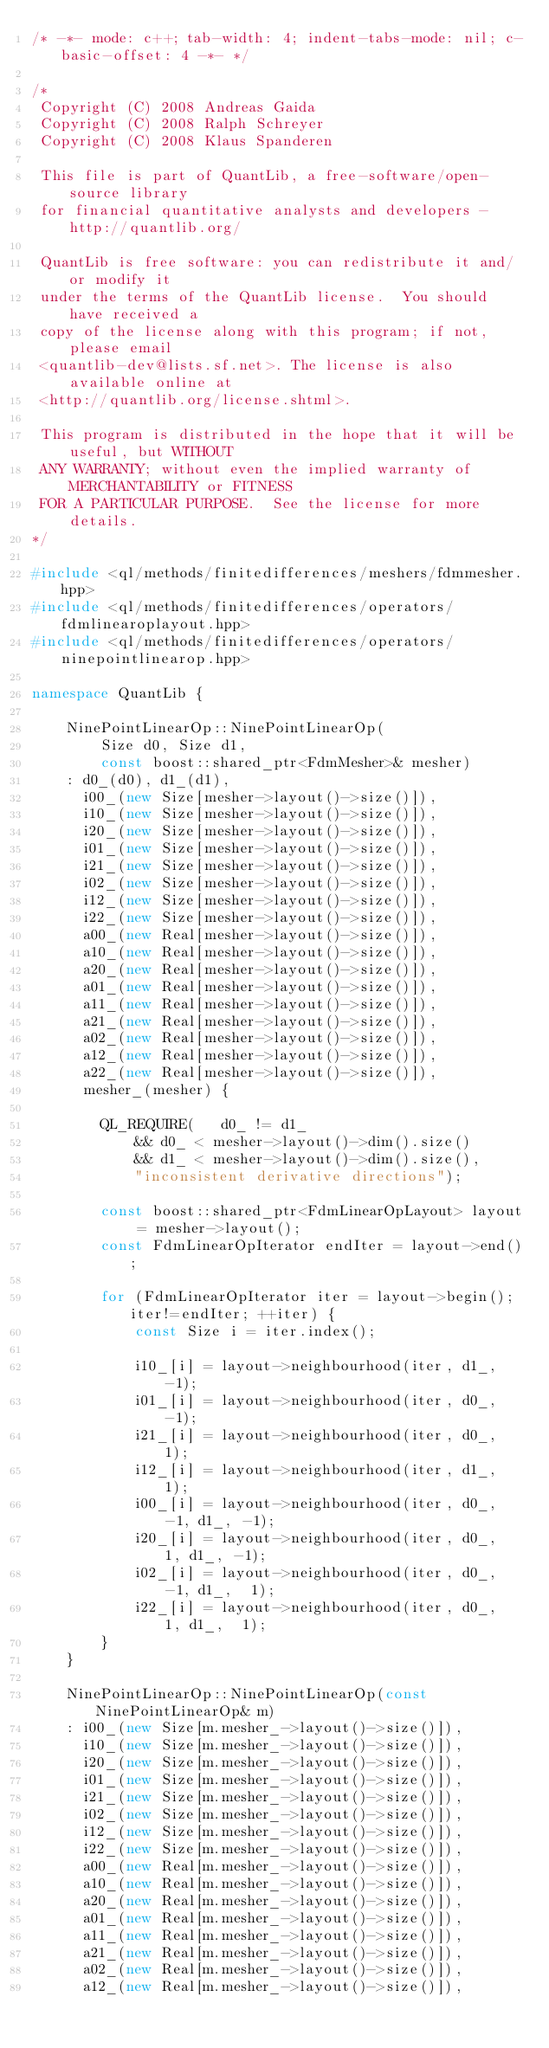Convert code to text. <code><loc_0><loc_0><loc_500><loc_500><_C++_>/* -*- mode: c++; tab-width: 4; indent-tabs-mode: nil; c-basic-offset: 4 -*- */

/*
 Copyright (C) 2008 Andreas Gaida
 Copyright (C) 2008 Ralph Schreyer
 Copyright (C) 2008 Klaus Spanderen

 This file is part of QuantLib, a free-software/open-source library
 for financial quantitative analysts and developers - http://quantlib.org/

 QuantLib is free software: you can redistribute it and/or modify it
 under the terms of the QuantLib license.  You should have received a
 copy of the license along with this program; if not, please email
 <quantlib-dev@lists.sf.net>. The license is also available online at
 <http://quantlib.org/license.shtml>.

 This program is distributed in the hope that it will be useful, but WITHOUT
 ANY WARRANTY; without even the implied warranty of MERCHANTABILITY or FITNESS
 FOR A PARTICULAR PURPOSE.  See the license for more details.
*/

#include <ql/methods/finitedifferences/meshers/fdmmesher.hpp>
#include <ql/methods/finitedifferences/operators/fdmlinearoplayout.hpp>
#include <ql/methods/finitedifferences/operators/ninepointlinearop.hpp>

namespace QuantLib {

    NinePointLinearOp::NinePointLinearOp(
        Size d0, Size d1,
        const boost::shared_ptr<FdmMesher>& mesher)
    : d0_(d0), d1_(d1),
      i00_(new Size[mesher->layout()->size()]),
      i10_(new Size[mesher->layout()->size()]),
      i20_(new Size[mesher->layout()->size()]),
      i01_(new Size[mesher->layout()->size()]),
      i21_(new Size[mesher->layout()->size()]),
      i02_(new Size[mesher->layout()->size()]),
      i12_(new Size[mesher->layout()->size()]),
      i22_(new Size[mesher->layout()->size()]),
      a00_(new Real[mesher->layout()->size()]),
      a10_(new Real[mesher->layout()->size()]),
      a20_(new Real[mesher->layout()->size()]),
      a01_(new Real[mesher->layout()->size()]),
      a11_(new Real[mesher->layout()->size()]),
      a21_(new Real[mesher->layout()->size()]),
      a02_(new Real[mesher->layout()->size()]),
      a12_(new Real[mesher->layout()->size()]),
      a22_(new Real[mesher->layout()->size()]),
      mesher_(mesher) {

        QL_REQUIRE(   d0_ != d1_
            && d0_ < mesher->layout()->dim().size()
            && d1_ < mesher->layout()->dim().size(),
            "inconsistent derivative directions");

        const boost::shared_ptr<FdmLinearOpLayout> layout = mesher->layout();
        const FdmLinearOpIterator endIter = layout->end();

        for (FdmLinearOpIterator iter = layout->begin(); iter!=endIter; ++iter) {
            const Size i = iter.index();

            i10_[i] = layout->neighbourhood(iter, d1_, -1);
            i01_[i] = layout->neighbourhood(iter, d0_, -1);
            i21_[i] = layout->neighbourhood(iter, d0_,  1);
            i12_[i] = layout->neighbourhood(iter, d1_,  1);
            i00_[i] = layout->neighbourhood(iter, d0_, -1, d1_, -1);
            i20_[i] = layout->neighbourhood(iter, d0_,  1, d1_, -1);
            i02_[i] = layout->neighbourhood(iter, d0_, -1, d1_,  1);
            i22_[i] = layout->neighbourhood(iter, d0_,  1, d1_,  1);
        }
    }

    NinePointLinearOp::NinePointLinearOp(const NinePointLinearOp& m)
    : i00_(new Size[m.mesher_->layout()->size()]),
      i10_(new Size[m.mesher_->layout()->size()]),
      i20_(new Size[m.mesher_->layout()->size()]),
      i01_(new Size[m.mesher_->layout()->size()]),
      i21_(new Size[m.mesher_->layout()->size()]),
      i02_(new Size[m.mesher_->layout()->size()]),
      i12_(new Size[m.mesher_->layout()->size()]),
      i22_(new Size[m.mesher_->layout()->size()]),
      a00_(new Real[m.mesher_->layout()->size()]),
      a10_(new Real[m.mesher_->layout()->size()]),
      a20_(new Real[m.mesher_->layout()->size()]),
      a01_(new Real[m.mesher_->layout()->size()]),
      a11_(new Real[m.mesher_->layout()->size()]),
      a21_(new Real[m.mesher_->layout()->size()]),
      a02_(new Real[m.mesher_->layout()->size()]),
      a12_(new Real[m.mesher_->layout()->size()]),</code> 